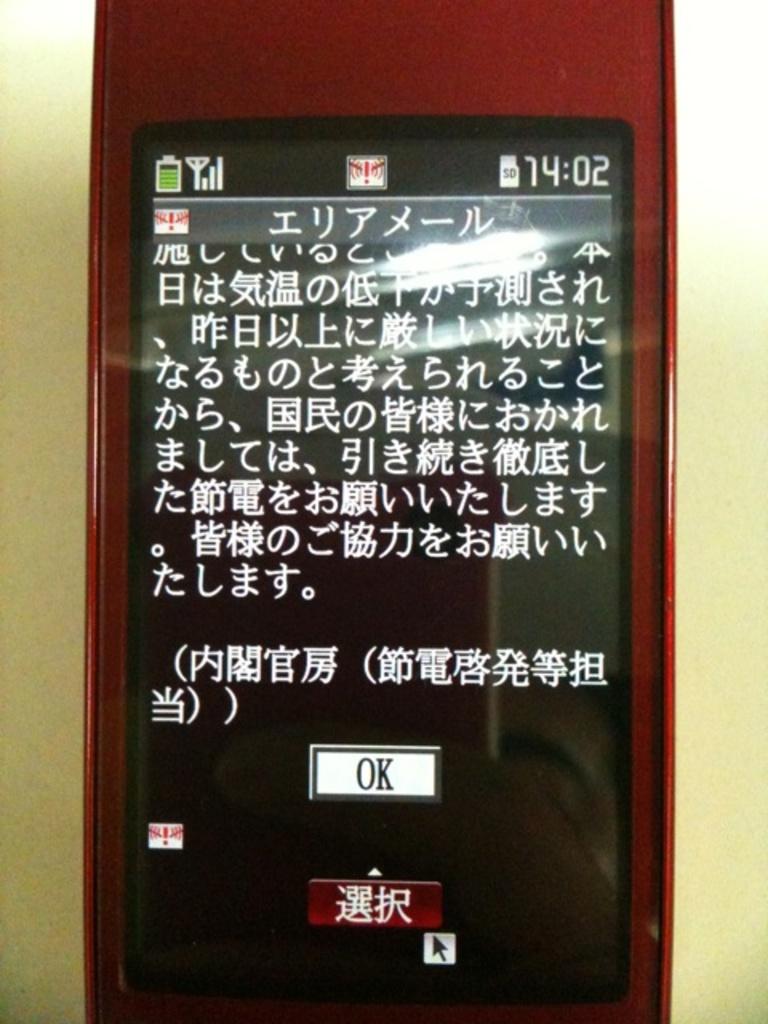What time is shown on the device?
Your response must be concise. 14:02. Is this a smart phone?
Make the answer very short. Yes. 